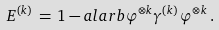<formula> <loc_0><loc_0><loc_500><loc_500>E ^ { ( k ) } \, = \, 1 - a l a r b { \varphi ^ { \otimes k } } { \gamma ^ { ( k ) } \, \varphi ^ { \otimes k } } \, .</formula> 